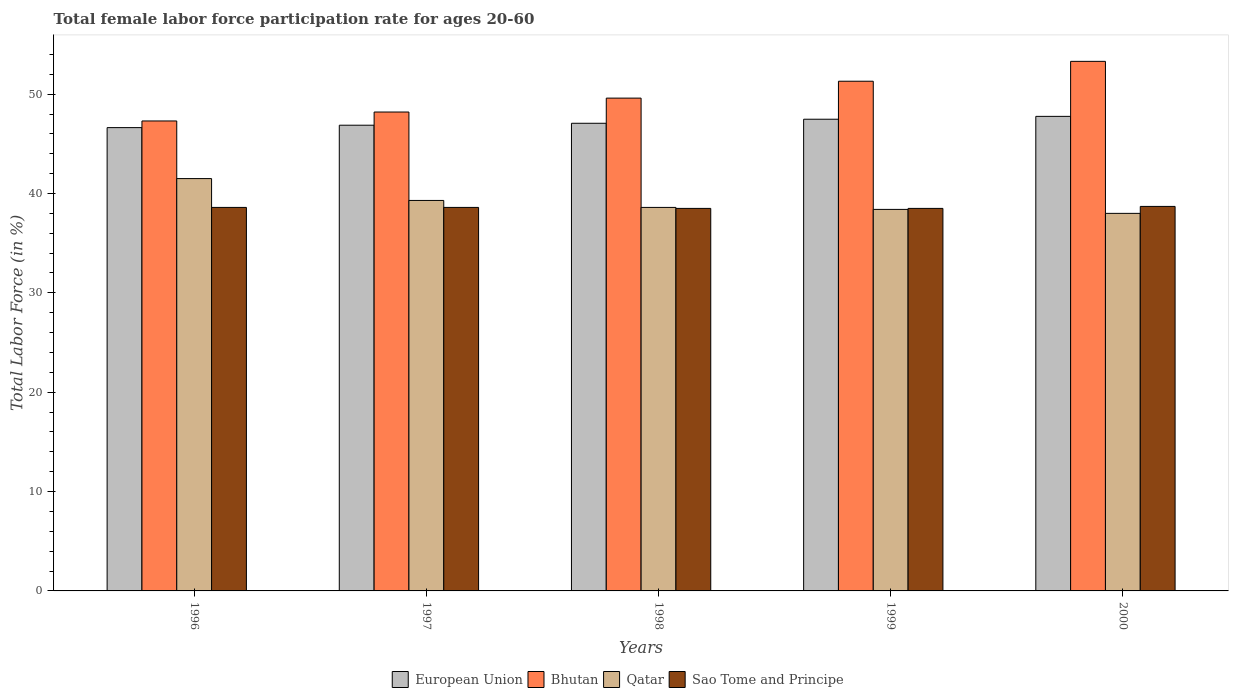Are the number of bars per tick equal to the number of legend labels?
Offer a very short reply. Yes. What is the label of the 3rd group of bars from the left?
Keep it short and to the point. 1998. What is the female labor force participation rate in Qatar in 1998?
Offer a terse response. 38.6. Across all years, what is the maximum female labor force participation rate in Qatar?
Provide a short and direct response. 41.5. Across all years, what is the minimum female labor force participation rate in Sao Tome and Principe?
Your response must be concise. 38.5. In which year was the female labor force participation rate in Qatar minimum?
Provide a succinct answer. 2000. What is the total female labor force participation rate in Bhutan in the graph?
Keep it short and to the point. 249.7. What is the difference between the female labor force participation rate in Qatar in 1997 and that in 2000?
Your answer should be compact. 1.3. What is the difference between the female labor force participation rate in Bhutan in 2000 and the female labor force participation rate in European Union in 1996?
Keep it short and to the point. 6.67. What is the average female labor force participation rate in Bhutan per year?
Offer a terse response. 49.94. In the year 1997, what is the difference between the female labor force participation rate in Qatar and female labor force participation rate in Sao Tome and Principe?
Your answer should be very brief. 0.7. What is the ratio of the female labor force participation rate in European Union in 1997 to that in 1998?
Ensure brevity in your answer.  1. Is the female labor force participation rate in Qatar in 1997 less than that in 1998?
Your response must be concise. No. What is the difference between the highest and the second highest female labor force participation rate in Bhutan?
Provide a short and direct response. 2. What is the difference between the highest and the lowest female labor force participation rate in Sao Tome and Principe?
Ensure brevity in your answer.  0.2. What does the 1st bar from the left in 1998 represents?
Make the answer very short. European Union. What does the 2nd bar from the right in 2000 represents?
Provide a short and direct response. Qatar. Is it the case that in every year, the sum of the female labor force participation rate in Qatar and female labor force participation rate in Bhutan is greater than the female labor force participation rate in European Union?
Offer a very short reply. Yes. How many bars are there?
Ensure brevity in your answer.  20. Does the graph contain any zero values?
Ensure brevity in your answer.  No. Where does the legend appear in the graph?
Give a very brief answer. Bottom center. How many legend labels are there?
Offer a very short reply. 4. What is the title of the graph?
Offer a very short reply. Total female labor force participation rate for ages 20-60. Does "Bermuda" appear as one of the legend labels in the graph?
Give a very brief answer. No. What is the Total Labor Force (in %) in European Union in 1996?
Your answer should be very brief. 46.63. What is the Total Labor Force (in %) in Bhutan in 1996?
Your response must be concise. 47.3. What is the Total Labor Force (in %) in Qatar in 1996?
Your response must be concise. 41.5. What is the Total Labor Force (in %) of Sao Tome and Principe in 1996?
Give a very brief answer. 38.6. What is the Total Labor Force (in %) in European Union in 1997?
Your response must be concise. 46.87. What is the Total Labor Force (in %) in Bhutan in 1997?
Offer a very short reply. 48.2. What is the Total Labor Force (in %) of Qatar in 1997?
Make the answer very short. 39.3. What is the Total Labor Force (in %) in Sao Tome and Principe in 1997?
Your response must be concise. 38.6. What is the Total Labor Force (in %) in European Union in 1998?
Make the answer very short. 47.07. What is the Total Labor Force (in %) in Bhutan in 1998?
Your response must be concise. 49.6. What is the Total Labor Force (in %) in Qatar in 1998?
Your response must be concise. 38.6. What is the Total Labor Force (in %) of Sao Tome and Principe in 1998?
Provide a short and direct response. 38.5. What is the Total Labor Force (in %) in European Union in 1999?
Keep it short and to the point. 47.48. What is the Total Labor Force (in %) in Bhutan in 1999?
Give a very brief answer. 51.3. What is the Total Labor Force (in %) in Qatar in 1999?
Keep it short and to the point. 38.4. What is the Total Labor Force (in %) in Sao Tome and Principe in 1999?
Your answer should be compact. 38.5. What is the Total Labor Force (in %) of European Union in 2000?
Give a very brief answer. 47.76. What is the Total Labor Force (in %) of Bhutan in 2000?
Your answer should be compact. 53.3. What is the Total Labor Force (in %) of Sao Tome and Principe in 2000?
Your answer should be very brief. 38.7. Across all years, what is the maximum Total Labor Force (in %) of European Union?
Provide a succinct answer. 47.76. Across all years, what is the maximum Total Labor Force (in %) in Bhutan?
Your answer should be compact. 53.3. Across all years, what is the maximum Total Labor Force (in %) of Qatar?
Your response must be concise. 41.5. Across all years, what is the maximum Total Labor Force (in %) in Sao Tome and Principe?
Make the answer very short. 38.7. Across all years, what is the minimum Total Labor Force (in %) in European Union?
Your answer should be compact. 46.63. Across all years, what is the minimum Total Labor Force (in %) of Bhutan?
Provide a short and direct response. 47.3. Across all years, what is the minimum Total Labor Force (in %) of Sao Tome and Principe?
Make the answer very short. 38.5. What is the total Total Labor Force (in %) of European Union in the graph?
Provide a short and direct response. 235.81. What is the total Total Labor Force (in %) of Bhutan in the graph?
Keep it short and to the point. 249.7. What is the total Total Labor Force (in %) in Qatar in the graph?
Keep it short and to the point. 195.8. What is the total Total Labor Force (in %) in Sao Tome and Principe in the graph?
Offer a terse response. 192.9. What is the difference between the Total Labor Force (in %) of European Union in 1996 and that in 1997?
Provide a short and direct response. -0.24. What is the difference between the Total Labor Force (in %) of Qatar in 1996 and that in 1997?
Your answer should be very brief. 2.2. What is the difference between the Total Labor Force (in %) of European Union in 1996 and that in 1998?
Provide a succinct answer. -0.44. What is the difference between the Total Labor Force (in %) of Qatar in 1996 and that in 1998?
Offer a terse response. 2.9. What is the difference between the Total Labor Force (in %) in European Union in 1996 and that in 1999?
Ensure brevity in your answer.  -0.85. What is the difference between the Total Labor Force (in %) of Bhutan in 1996 and that in 1999?
Your answer should be compact. -4. What is the difference between the Total Labor Force (in %) in Qatar in 1996 and that in 1999?
Provide a short and direct response. 3.1. What is the difference between the Total Labor Force (in %) in European Union in 1996 and that in 2000?
Your answer should be very brief. -1.13. What is the difference between the Total Labor Force (in %) in Sao Tome and Principe in 1996 and that in 2000?
Offer a very short reply. -0.1. What is the difference between the Total Labor Force (in %) in European Union in 1997 and that in 1998?
Keep it short and to the point. -0.19. What is the difference between the Total Labor Force (in %) in Bhutan in 1997 and that in 1998?
Keep it short and to the point. -1.4. What is the difference between the Total Labor Force (in %) in Qatar in 1997 and that in 1998?
Keep it short and to the point. 0.7. What is the difference between the Total Labor Force (in %) in European Union in 1997 and that in 1999?
Ensure brevity in your answer.  -0.6. What is the difference between the Total Labor Force (in %) of Qatar in 1997 and that in 1999?
Ensure brevity in your answer.  0.9. What is the difference between the Total Labor Force (in %) of Sao Tome and Principe in 1997 and that in 1999?
Keep it short and to the point. 0.1. What is the difference between the Total Labor Force (in %) in European Union in 1997 and that in 2000?
Provide a short and direct response. -0.89. What is the difference between the Total Labor Force (in %) in Qatar in 1997 and that in 2000?
Ensure brevity in your answer.  1.3. What is the difference between the Total Labor Force (in %) in European Union in 1998 and that in 1999?
Offer a terse response. -0.41. What is the difference between the Total Labor Force (in %) of Bhutan in 1998 and that in 1999?
Provide a succinct answer. -1.7. What is the difference between the Total Labor Force (in %) in Qatar in 1998 and that in 1999?
Offer a terse response. 0.2. What is the difference between the Total Labor Force (in %) in European Union in 1998 and that in 2000?
Make the answer very short. -0.69. What is the difference between the Total Labor Force (in %) in Sao Tome and Principe in 1998 and that in 2000?
Keep it short and to the point. -0.2. What is the difference between the Total Labor Force (in %) of European Union in 1999 and that in 2000?
Ensure brevity in your answer.  -0.29. What is the difference between the Total Labor Force (in %) of Bhutan in 1999 and that in 2000?
Your answer should be compact. -2. What is the difference between the Total Labor Force (in %) in Sao Tome and Principe in 1999 and that in 2000?
Give a very brief answer. -0.2. What is the difference between the Total Labor Force (in %) in European Union in 1996 and the Total Labor Force (in %) in Bhutan in 1997?
Provide a short and direct response. -1.57. What is the difference between the Total Labor Force (in %) in European Union in 1996 and the Total Labor Force (in %) in Qatar in 1997?
Provide a short and direct response. 7.33. What is the difference between the Total Labor Force (in %) in European Union in 1996 and the Total Labor Force (in %) in Sao Tome and Principe in 1997?
Ensure brevity in your answer.  8.03. What is the difference between the Total Labor Force (in %) in Bhutan in 1996 and the Total Labor Force (in %) in Qatar in 1997?
Provide a short and direct response. 8. What is the difference between the Total Labor Force (in %) in Bhutan in 1996 and the Total Labor Force (in %) in Sao Tome and Principe in 1997?
Provide a succinct answer. 8.7. What is the difference between the Total Labor Force (in %) in Qatar in 1996 and the Total Labor Force (in %) in Sao Tome and Principe in 1997?
Ensure brevity in your answer.  2.9. What is the difference between the Total Labor Force (in %) in European Union in 1996 and the Total Labor Force (in %) in Bhutan in 1998?
Your answer should be very brief. -2.97. What is the difference between the Total Labor Force (in %) in European Union in 1996 and the Total Labor Force (in %) in Qatar in 1998?
Your answer should be compact. 8.03. What is the difference between the Total Labor Force (in %) of European Union in 1996 and the Total Labor Force (in %) of Sao Tome and Principe in 1998?
Ensure brevity in your answer.  8.13. What is the difference between the Total Labor Force (in %) of Qatar in 1996 and the Total Labor Force (in %) of Sao Tome and Principe in 1998?
Provide a succinct answer. 3. What is the difference between the Total Labor Force (in %) in European Union in 1996 and the Total Labor Force (in %) in Bhutan in 1999?
Provide a short and direct response. -4.67. What is the difference between the Total Labor Force (in %) of European Union in 1996 and the Total Labor Force (in %) of Qatar in 1999?
Give a very brief answer. 8.23. What is the difference between the Total Labor Force (in %) of European Union in 1996 and the Total Labor Force (in %) of Sao Tome and Principe in 1999?
Provide a short and direct response. 8.13. What is the difference between the Total Labor Force (in %) in Bhutan in 1996 and the Total Labor Force (in %) in Qatar in 1999?
Offer a terse response. 8.9. What is the difference between the Total Labor Force (in %) in Qatar in 1996 and the Total Labor Force (in %) in Sao Tome and Principe in 1999?
Your answer should be very brief. 3. What is the difference between the Total Labor Force (in %) of European Union in 1996 and the Total Labor Force (in %) of Bhutan in 2000?
Offer a terse response. -6.67. What is the difference between the Total Labor Force (in %) in European Union in 1996 and the Total Labor Force (in %) in Qatar in 2000?
Provide a short and direct response. 8.63. What is the difference between the Total Labor Force (in %) of European Union in 1996 and the Total Labor Force (in %) of Sao Tome and Principe in 2000?
Ensure brevity in your answer.  7.93. What is the difference between the Total Labor Force (in %) of Bhutan in 1996 and the Total Labor Force (in %) of Qatar in 2000?
Give a very brief answer. 9.3. What is the difference between the Total Labor Force (in %) in Bhutan in 1996 and the Total Labor Force (in %) in Sao Tome and Principe in 2000?
Give a very brief answer. 8.6. What is the difference between the Total Labor Force (in %) in European Union in 1997 and the Total Labor Force (in %) in Bhutan in 1998?
Give a very brief answer. -2.73. What is the difference between the Total Labor Force (in %) of European Union in 1997 and the Total Labor Force (in %) of Qatar in 1998?
Make the answer very short. 8.27. What is the difference between the Total Labor Force (in %) in European Union in 1997 and the Total Labor Force (in %) in Sao Tome and Principe in 1998?
Your answer should be very brief. 8.37. What is the difference between the Total Labor Force (in %) of Bhutan in 1997 and the Total Labor Force (in %) of Sao Tome and Principe in 1998?
Your response must be concise. 9.7. What is the difference between the Total Labor Force (in %) in Qatar in 1997 and the Total Labor Force (in %) in Sao Tome and Principe in 1998?
Provide a short and direct response. 0.8. What is the difference between the Total Labor Force (in %) in European Union in 1997 and the Total Labor Force (in %) in Bhutan in 1999?
Keep it short and to the point. -4.43. What is the difference between the Total Labor Force (in %) of European Union in 1997 and the Total Labor Force (in %) of Qatar in 1999?
Your answer should be compact. 8.47. What is the difference between the Total Labor Force (in %) of European Union in 1997 and the Total Labor Force (in %) of Sao Tome and Principe in 1999?
Provide a succinct answer. 8.37. What is the difference between the Total Labor Force (in %) of Bhutan in 1997 and the Total Labor Force (in %) of Sao Tome and Principe in 1999?
Provide a succinct answer. 9.7. What is the difference between the Total Labor Force (in %) in Qatar in 1997 and the Total Labor Force (in %) in Sao Tome and Principe in 1999?
Provide a short and direct response. 0.8. What is the difference between the Total Labor Force (in %) of European Union in 1997 and the Total Labor Force (in %) of Bhutan in 2000?
Your response must be concise. -6.43. What is the difference between the Total Labor Force (in %) of European Union in 1997 and the Total Labor Force (in %) of Qatar in 2000?
Offer a terse response. 8.87. What is the difference between the Total Labor Force (in %) in European Union in 1997 and the Total Labor Force (in %) in Sao Tome and Principe in 2000?
Provide a short and direct response. 8.17. What is the difference between the Total Labor Force (in %) of European Union in 1998 and the Total Labor Force (in %) of Bhutan in 1999?
Provide a short and direct response. -4.23. What is the difference between the Total Labor Force (in %) of European Union in 1998 and the Total Labor Force (in %) of Qatar in 1999?
Your response must be concise. 8.67. What is the difference between the Total Labor Force (in %) in European Union in 1998 and the Total Labor Force (in %) in Sao Tome and Principe in 1999?
Offer a very short reply. 8.57. What is the difference between the Total Labor Force (in %) in Bhutan in 1998 and the Total Labor Force (in %) in Sao Tome and Principe in 1999?
Give a very brief answer. 11.1. What is the difference between the Total Labor Force (in %) in European Union in 1998 and the Total Labor Force (in %) in Bhutan in 2000?
Keep it short and to the point. -6.23. What is the difference between the Total Labor Force (in %) of European Union in 1998 and the Total Labor Force (in %) of Qatar in 2000?
Give a very brief answer. 9.07. What is the difference between the Total Labor Force (in %) in European Union in 1998 and the Total Labor Force (in %) in Sao Tome and Principe in 2000?
Provide a succinct answer. 8.37. What is the difference between the Total Labor Force (in %) of Bhutan in 1998 and the Total Labor Force (in %) of Qatar in 2000?
Keep it short and to the point. 11.6. What is the difference between the Total Labor Force (in %) of European Union in 1999 and the Total Labor Force (in %) of Bhutan in 2000?
Your response must be concise. -5.82. What is the difference between the Total Labor Force (in %) in European Union in 1999 and the Total Labor Force (in %) in Qatar in 2000?
Provide a succinct answer. 9.48. What is the difference between the Total Labor Force (in %) of European Union in 1999 and the Total Labor Force (in %) of Sao Tome and Principe in 2000?
Ensure brevity in your answer.  8.78. What is the difference between the Total Labor Force (in %) in Qatar in 1999 and the Total Labor Force (in %) in Sao Tome and Principe in 2000?
Offer a very short reply. -0.3. What is the average Total Labor Force (in %) of European Union per year?
Offer a very short reply. 47.16. What is the average Total Labor Force (in %) in Bhutan per year?
Your answer should be compact. 49.94. What is the average Total Labor Force (in %) in Qatar per year?
Provide a succinct answer. 39.16. What is the average Total Labor Force (in %) in Sao Tome and Principe per year?
Give a very brief answer. 38.58. In the year 1996, what is the difference between the Total Labor Force (in %) in European Union and Total Labor Force (in %) in Bhutan?
Your answer should be compact. -0.67. In the year 1996, what is the difference between the Total Labor Force (in %) of European Union and Total Labor Force (in %) of Qatar?
Keep it short and to the point. 5.13. In the year 1996, what is the difference between the Total Labor Force (in %) in European Union and Total Labor Force (in %) in Sao Tome and Principe?
Make the answer very short. 8.03. In the year 1997, what is the difference between the Total Labor Force (in %) of European Union and Total Labor Force (in %) of Bhutan?
Offer a terse response. -1.33. In the year 1997, what is the difference between the Total Labor Force (in %) in European Union and Total Labor Force (in %) in Qatar?
Keep it short and to the point. 7.57. In the year 1997, what is the difference between the Total Labor Force (in %) of European Union and Total Labor Force (in %) of Sao Tome and Principe?
Offer a terse response. 8.27. In the year 1998, what is the difference between the Total Labor Force (in %) of European Union and Total Labor Force (in %) of Bhutan?
Make the answer very short. -2.53. In the year 1998, what is the difference between the Total Labor Force (in %) of European Union and Total Labor Force (in %) of Qatar?
Ensure brevity in your answer.  8.47. In the year 1998, what is the difference between the Total Labor Force (in %) in European Union and Total Labor Force (in %) in Sao Tome and Principe?
Your response must be concise. 8.57. In the year 1998, what is the difference between the Total Labor Force (in %) in Bhutan and Total Labor Force (in %) in Sao Tome and Principe?
Offer a terse response. 11.1. In the year 1998, what is the difference between the Total Labor Force (in %) of Qatar and Total Labor Force (in %) of Sao Tome and Principe?
Offer a very short reply. 0.1. In the year 1999, what is the difference between the Total Labor Force (in %) of European Union and Total Labor Force (in %) of Bhutan?
Your response must be concise. -3.82. In the year 1999, what is the difference between the Total Labor Force (in %) of European Union and Total Labor Force (in %) of Qatar?
Keep it short and to the point. 9.08. In the year 1999, what is the difference between the Total Labor Force (in %) in European Union and Total Labor Force (in %) in Sao Tome and Principe?
Your response must be concise. 8.98. In the year 1999, what is the difference between the Total Labor Force (in %) of Bhutan and Total Labor Force (in %) of Qatar?
Make the answer very short. 12.9. In the year 1999, what is the difference between the Total Labor Force (in %) in Bhutan and Total Labor Force (in %) in Sao Tome and Principe?
Your answer should be very brief. 12.8. In the year 2000, what is the difference between the Total Labor Force (in %) in European Union and Total Labor Force (in %) in Bhutan?
Provide a short and direct response. -5.54. In the year 2000, what is the difference between the Total Labor Force (in %) of European Union and Total Labor Force (in %) of Qatar?
Give a very brief answer. 9.76. In the year 2000, what is the difference between the Total Labor Force (in %) of European Union and Total Labor Force (in %) of Sao Tome and Principe?
Provide a short and direct response. 9.06. In the year 2000, what is the difference between the Total Labor Force (in %) of Qatar and Total Labor Force (in %) of Sao Tome and Principe?
Give a very brief answer. -0.7. What is the ratio of the Total Labor Force (in %) in European Union in 1996 to that in 1997?
Your response must be concise. 0.99. What is the ratio of the Total Labor Force (in %) in Bhutan in 1996 to that in 1997?
Your answer should be very brief. 0.98. What is the ratio of the Total Labor Force (in %) of Qatar in 1996 to that in 1997?
Ensure brevity in your answer.  1.06. What is the ratio of the Total Labor Force (in %) of Sao Tome and Principe in 1996 to that in 1997?
Your response must be concise. 1. What is the ratio of the Total Labor Force (in %) of European Union in 1996 to that in 1998?
Give a very brief answer. 0.99. What is the ratio of the Total Labor Force (in %) of Bhutan in 1996 to that in 1998?
Ensure brevity in your answer.  0.95. What is the ratio of the Total Labor Force (in %) in Qatar in 1996 to that in 1998?
Your response must be concise. 1.08. What is the ratio of the Total Labor Force (in %) in European Union in 1996 to that in 1999?
Your answer should be very brief. 0.98. What is the ratio of the Total Labor Force (in %) of Bhutan in 1996 to that in 1999?
Provide a succinct answer. 0.92. What is the ratio of the Total Labor Force (in %) in Qatar in 1996 to that in 1999?
Provide a succinct answer. 1.08. What is the ratio of the Total Labor Force (in %) in European Union in 1996 to that in 2000?
Offer a terse response. 0.98. What is the ratio of the Total Labor Force (in %) in Bhutan in 1996 to that in 2000?
Your answer should be compact. 0.89. What is the ratio of the Total Labor Force (in %) of Qatar in 1996 to that in 2000?
Offer a terse response. 1.09. What is the ratio of the Total Labor Force (in %) in Sao Tome and Principe in 1996 to that in 2000?
Your response must be concise. 1. What is the ratio of the Total Labor Force (in %) in Bhutan in 1997 to that in 1998?
Give a very brief answer. 0.97. What is the ratio of the Total Labor Force (in %) in Qatar in 1997 to that in 1998?
Provide a succinct answer. 1.02. What is the ratio of the Total Labor Force (in %) of Sao Tome and Principe in 1997 to that in 1998?
Offer a very short reply. 1. What is the ratio of the Total Labor Force (in %) of European Union in 1997 to that in 1999?
Give a very brief answer. 0.99. What is the ratio of the Total Labor Force (in %) in Bhutan in 1997 to that in 1999?
Offer a terse response. 0.94. What is the ratio of the Total Labor Force (in %) of Qatar in 1997 to that in 1999?
Provide a succinct answer. 1.02. What is the ratio of the Total Labor Force (in %) of European Union in 1997 to that in 2000?
Keep it short and to the point. 0.98. What is the ratio of the Total Labor Force (in %) in Bhutan in 1997 to that in 2000?
Make the answer very short. 0.9. What is the ratio of the Total Labor Force (in %) in Qatar in 1997 to that in 2000?
Provide a short and direct response. 1.03. What is the ratio of the Total Labor Force (in %) in Bhutan in 1998 to that in 1999?
Offer a terse response. 0.97. What is the ratio of the Total Labor Force (in %) in European Union in 1998 to that in 2000?
Provide a succinct answer. 0.99. What is the ratio of the Total Labor Force (in %) of Bhutan in 1998 to that in 2000?
Your response must be concise. 0.93. What is the ratio of the Total Labor Force (in %) of Qatar in 1998 to that in 2000?
Make the answer very short. 1.02. What is the ratio of the Total Labor Force (in %) in Sao Tome and Principe in 1998 to that in 2000?
Make the answer very short. 0.99. What is the ratio of the Total Labor Force (in %) of European Union in 1999 to that in 2000?
Offer a very short reply. 0.99. What is the ratio of the Total Labor Force (in %) of Bhutan in 1999 to that in 2000?
Make the answer very short. 0.96. What is the ratio of the Total Labor Force (in %) of Qatar in 1999 to that in 2000?
Make the answer very short. 1.01. What is the difference between the highest and the second highest Total Labor Force (in %) in European Union?
Offer a very short reply. 0.29. What is the difference between the highest and the second highest Total Labor Force (in %) of Sao Tome and Principe?
Provide a short and direct response. 0.1. What is the difference between the highest and the lowest Total Labor Force (in %) of European Union?
Make the answer very short. 1.13. What is the difference between the highest and the lowest Total Labor Force (in %) in Qatar?
Your answer should be compact. 3.5. 